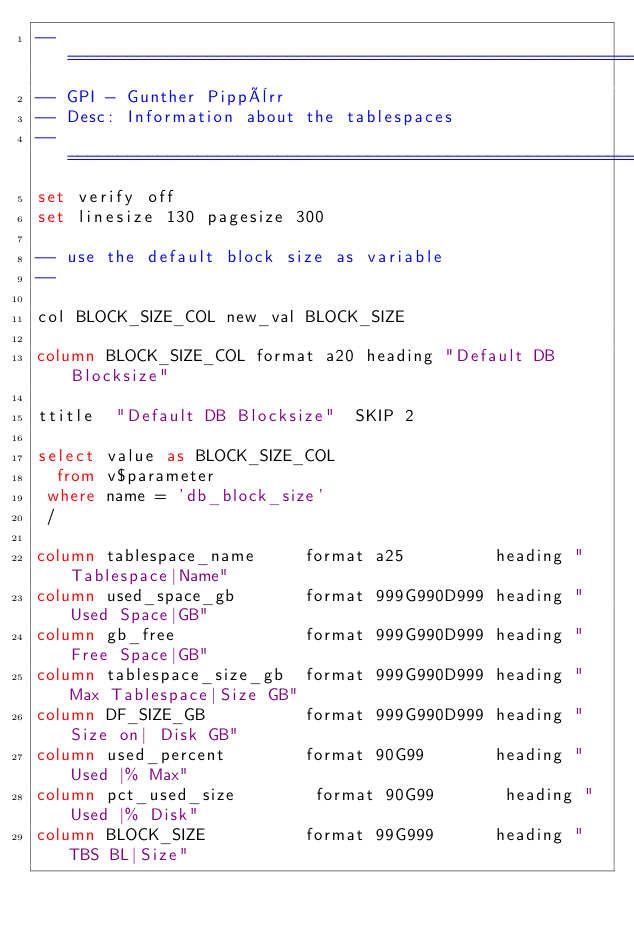<code> <loc_0><loc_0><loc_500><loc_500><_SQL_>--==============================================================================
-- GPI - Gunther Pippèrr
-- Desc: Information about the tablespaces
--==============================================================================
set verify off
set linesize 130 pagesize 300 

-- use the default block size as variable
-- 

col BLOCK_SIZE_COL new_val BLOCK_SIZE

column BLOCK_SIZE_COL format a20 heading "Default DB Blocksize"
 
ttitle  "Default DB Blocksize"  SKIP 2

select value as BLOCK_SIZE_COL
  from v$parameter 
 where name = 'db_block_size'
 /

column tablespace_name     format a25         heading "Tablespace|Name"
column used_space_gb       format 999G990D999 heading "Used Space|GB"
column gb_free             format 999G990D999 heading "Free Space|GB"
column tablespace_size_gb  format 999G990D999 heading "Max Tablespace|Size GB"
column DF_SIZE_GB          format 999G990D999 heading "Size on| Disk GB"
column used_percent        format 90G99       heading "Used |% Max"  
column pct_used_size        format 90G99       heading "Used |% Disk"  
column BLOCK_SIZE          format 99G999      heading "TBS BL|Size"  </code> 